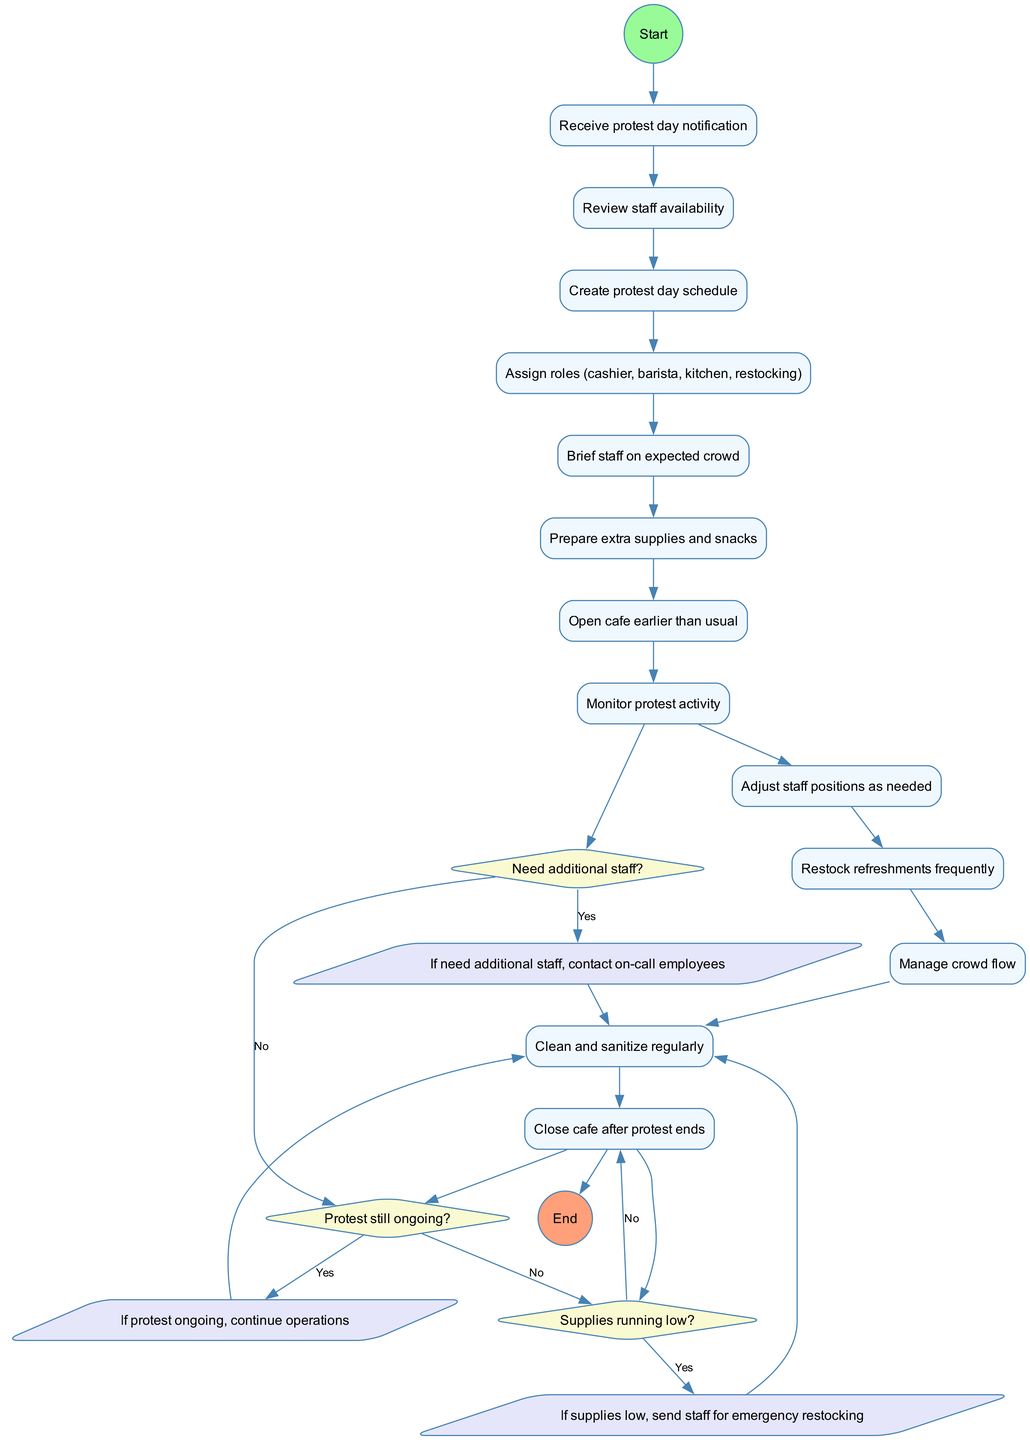What is the first activity in the diagram? The first activity is labeled as "Receive protest day notification," which is the immediate action after the start node.
Answer: Receive protest day notification How many activities are shown in the diagram? There are a total of twelve activities listed in the "activities" section, which can be counted directly from it.
Answer: 12 What decision follows the activity of "Clean and sanitize regularly"? The decision that follows is "Need additional staff?" as it directly connects from the last activity in the flow.
Answer: Need additional staff? What happens if the answer to "Need additional staff?" is yes? If the answer is yes, the flow directs to "contact on-call employees," meaning additional staff will be contacted as necessitated by the situation.
Answer: Contact on-call employees After "Restock refreshments frequently," which activity is next in the flow? The next activity after "Restock refreshments frequently" is "Manage crowd flow," indicating that crowd management will be addressed following restocking.
Answer: Manage crowd flow How many decisions are present in the diagram? The diagram contains three decisions, which can be identified in the "decisions" section where they are explicitly listed.
Answer: 3 What is the last activity performed before the cafe closes? The last activity listed before the closing is "Close cafe after protest ends," indicating the end of operations for the day.
Answer: Close cafe after protest ends If supplies are running low, what action is taken? If supplies are running low, the flow indicates that staff will be sent for emergency restocking, which is necessary to ensure cafe operations continue smoothly.
Answer: Send staff for emergency restocking Which activity occurs directly after "Brief staff on expected crowd"? Directly following "Brief staff on expected crowd," the activity is "Prepare extra supplies and snacks," showing the proactive measures taken for managing the crowd.
Answer: Prepare extra supplies and snacks 